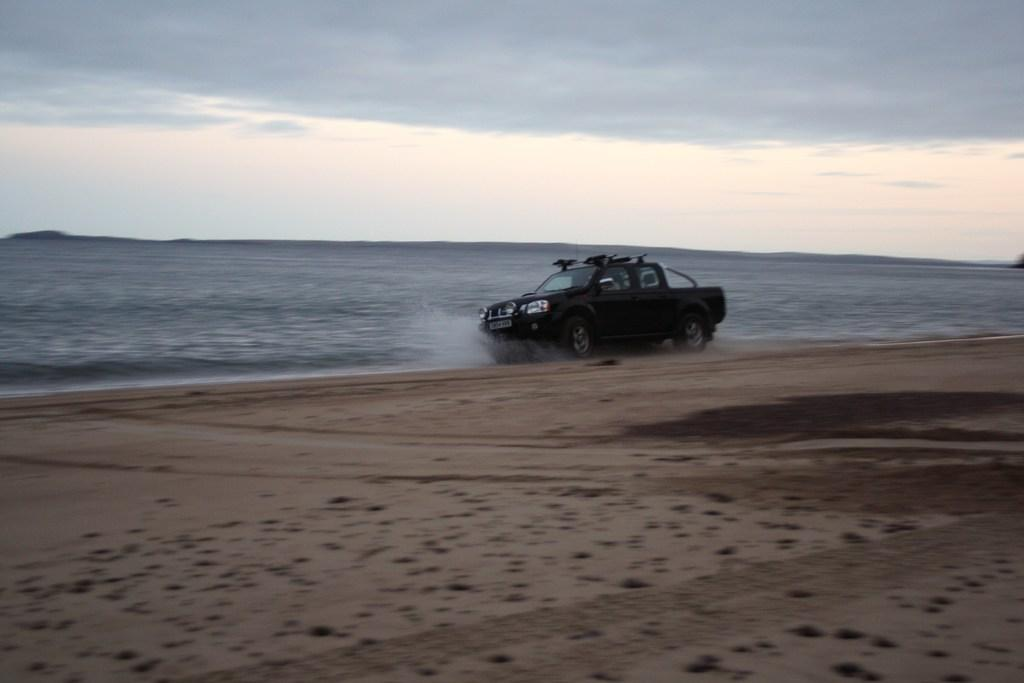What type of vehicle is in the image? There is a vehicle in the image, but the specific type is not mentioned. What color is the vehicle in the image? The vehicle is black in color. What natural setting is visible in the image? There is a beach visible in the image. What is the condition of the sky in the image? The sky is cloudy in the image. Can you tell me how many sponges are on the beach in the image? There is no mention of sponges in the image, so it is not possible to determine their quantity. What level of respect is being shown by the vehicle in the image? The image does not convey any information about the level of respect being shown by the vehicle. 